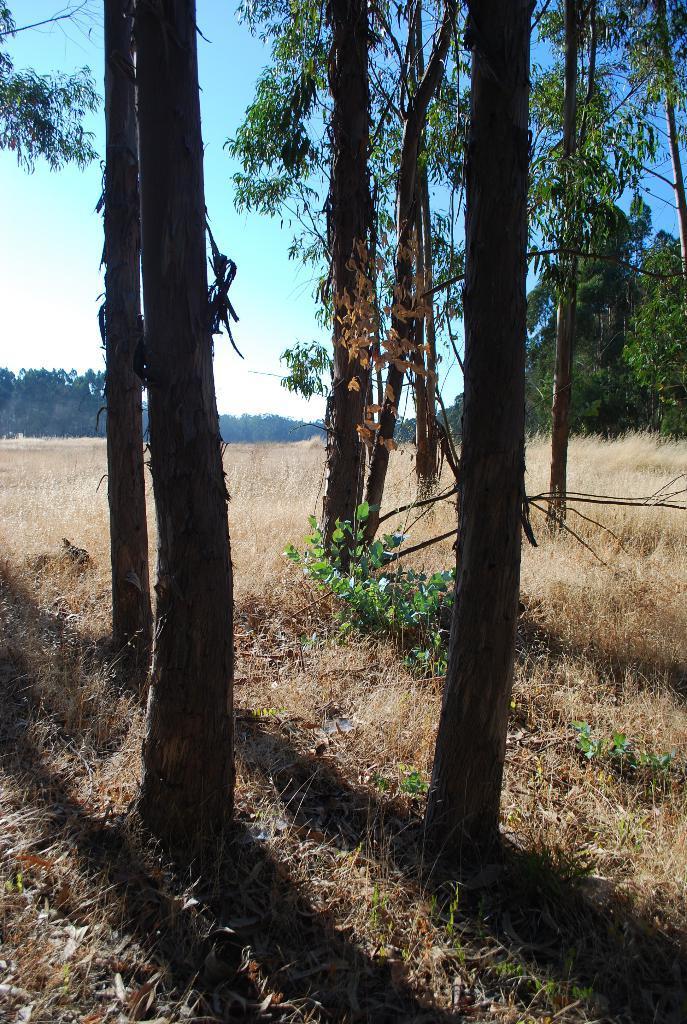Could you give a brief overview of what you see in this image? In this image there is the sky, there are trees truncated towards the top of the image, there are trees truncated towards the right of the image, there are trees truncated towards the left of the image, there are plants, there are plants truncated towards the right of the image, there are plants truncated towards the bottom of the image, there are plants truncated towards the left of the image. 